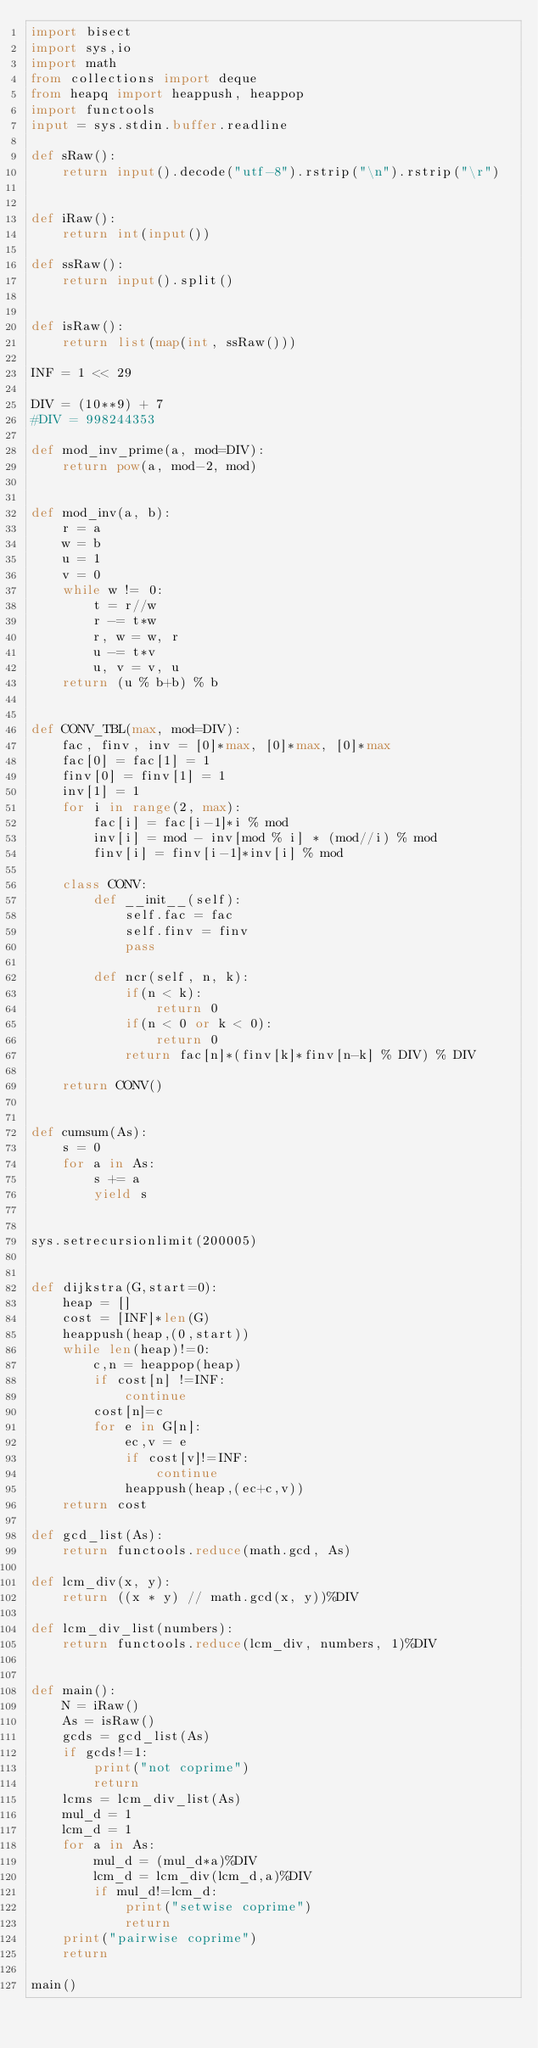Convert code to text. <code><loc_0><loc_0><loc_500><loc_500><_Python_>import bisect
import sys,io
import math
from collections import deque
from heapq import heappush, heappop
import functools
input = sys.stdin.buffer.readline

def sRaw():
    return input().decode("utf-8").rstrip("\n").rstrip("\r")


def iRaw():
    return int(input())

def ssRaw():
    return input().split()


def isRaw():
    return list(map(int, ssRaw()))

INF = 1 << 29

DIV = (10**9) + 7
#DIV = 998244353

def mod_inv_prime(a, mod=DIV):
    return pow(a, mod-2, mod)


def mod_inv(a, b):
    r = a
    w = b
    u = 1
    v = 0
    while w != 0:
        t = r//w
        r -= t*w
        r, w = w, r
        u -= t*v
        u, v = v, u
    return (u % b+b) % b


def CONV_TBL(max, mod=DIV):
    fac, finv, inv = [0]*max, [0]*max, [0]*max
    fac[0] = fac[1] = 1
    finv[0] = finv[1] = 1
    inv[1] = 1
    for i in range(2, max):
        fac[i] = fac[i-1]*i % mod
        inv[i] = mod - inv[mod % i] * (mod//i) % mod
        finv[i] = finv[i-1]*inv[i] % mod

    class CONV:
        def __init__(self):
            self.fac = fac
            self.finv = finv
            pass

        def ncr(self, n, k):
            if(n < k):
                return 0
            if(n < 0 or k < 0):
                return 0
            return fac[n]*(finv[k]*finv[n-k] % DIV) % DIV

    return CONV()


def cumsum(As):
    s = 0
    for a in As:
        s += a
        yield s


sys.setrecursionlimit(200005)


def dijkstra(G,start=0):
    heap = []
    cost = [INF]*len(G)
    heappush(heap,(0,start))
    while len(heap)!=0:
        c,n = heappop(heap)
        if cost[n] !=INF:
            continue
        cost[n]=c
        for e in G[n]:
            ec,v = e
            if cost[v]!=INF:
                continue
            heappush(heap,(ec+c,v))
    return cost

def gcd_list(As):
    return functools.reduce(math.gcd, As)

def lcm_div(x, y):
    return ((x * y) // math.gcd(x, y))%DIV

def lcm_div_list(numbers):
    return functools.reduce(lcm_div, numbers, 1)%DIV


def main():
    N = iRaw()
    As = isRaw()
    gcds = gcd_list(As)
    if gcds!=1:
        print("not coprime")
        return
    lcms = lcm_div_list(As)
    mul_d = 1
    lcm_d = 1
    for a in As:
        mul_d = (mul_d*a)%DIV
        lcm_d = lcm_div(lcm_d,a)%DIV
        if mul_d!=lcm_d:
            print("setwise coprime")
            return
    print("pairwise coprime")
    return
    
main()
</code> 